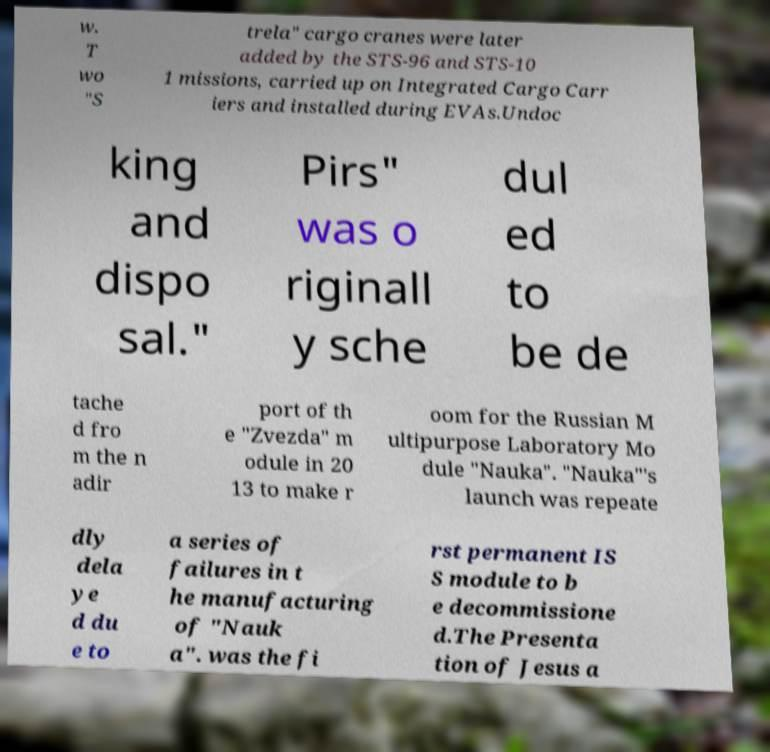Please read and relay the text visible in this image. What does it say? w. T wo "S trela" cargo cranes were later added by the STS-96 and STS-10 1 missions, carried up on Integrated Cargo Carr iers and installed during EVAs.Undoc king and dispo sal." Pirs" was o riginall y sche dul ed to be de tache d fro m the n adir port of th e "Zvezda" m odule in 20 13 to make r oom for the Russian M ultipurpose Laboratory Mo dule "Nauka". "Nauka"'s launch was repeate dly dela ye d du e to a series of failures in t he manufacturing of "Nauk a". was the fi rst permanent IS S module to b e decommissione d.The Presenta tion of Jesus a 